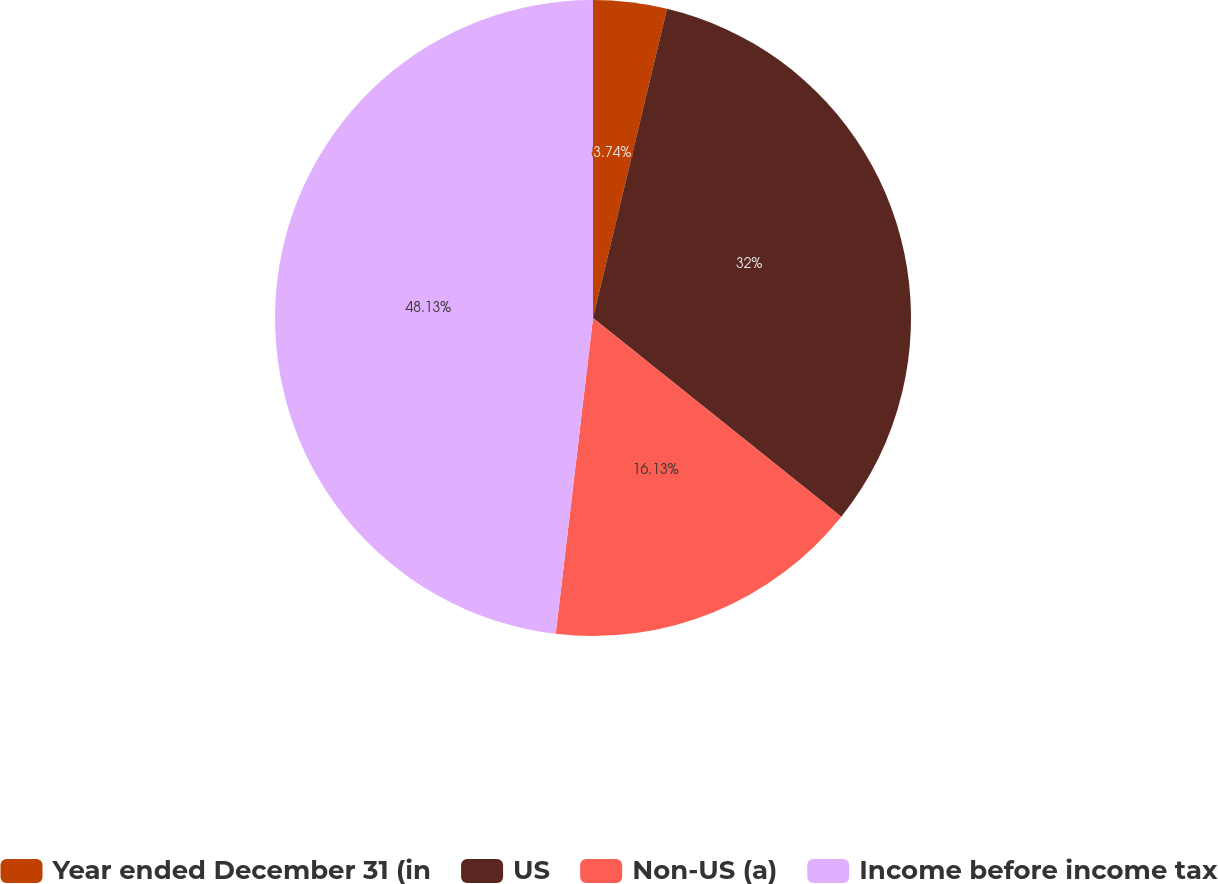<chart> <loc_0><loc_0><loc_500><loc_500><pie_chart><fcel>Year ended December 31 (in<fcel>US<fcel>Non-US (a)<fcel>Income before income tax<nl><fcel>3.74%<fcel>32.0%<fcel>16.13%<fcel>48.13%<nl></chart> 